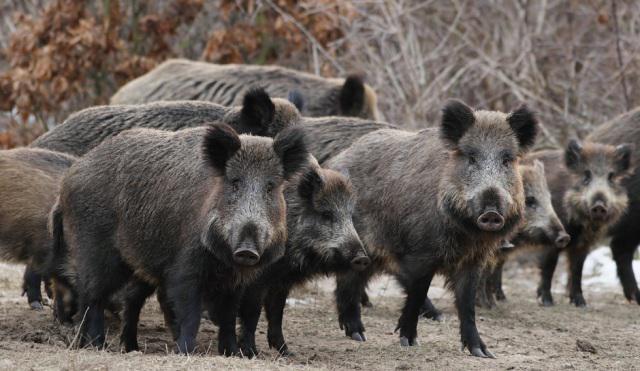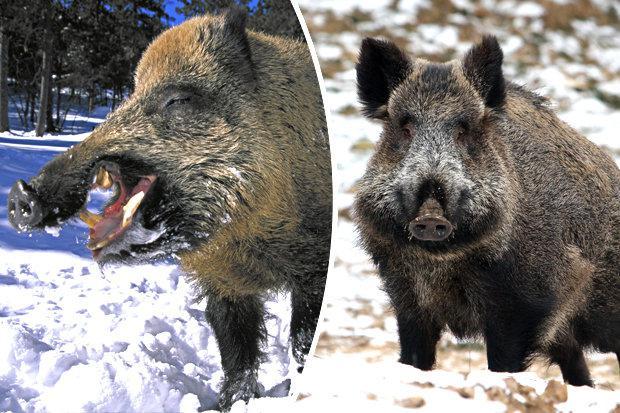The first image is the image on the left, the second image is the image on the right. Evaluate the accuracy of this statement regarding the images: "The image on the left shows a single warthog.". Is it true? Answer yes or no. No. The first image is the image on the left, the second image is the image on the right. Given the left and right images, does the statement "The left image contains at least three times as many wild pigs as the right image." hold true? Answer yes or no. Yes. 